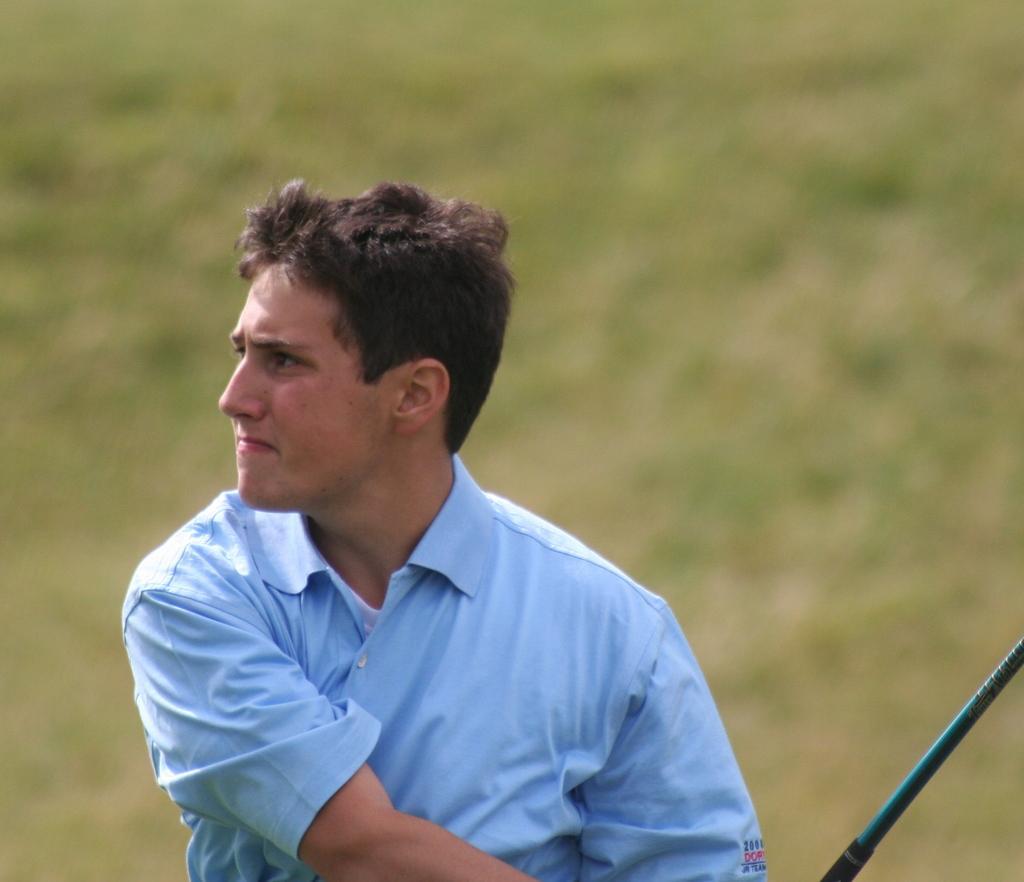Describe this image in one or two sentences. In this picture we can see a man holding a stick. Behind the man, there is a blurred background. 